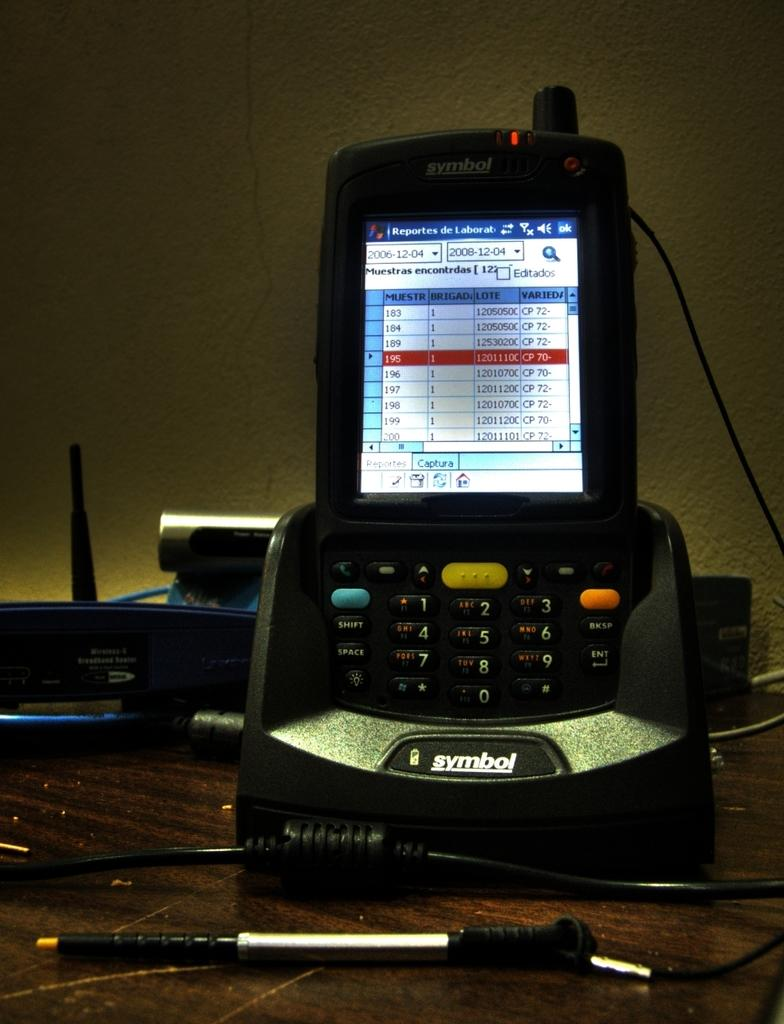<image>
Give a short and clear explanation of the subsequent image. A symbol brand of phone is showing Reportes de Labor at the chart below it. 